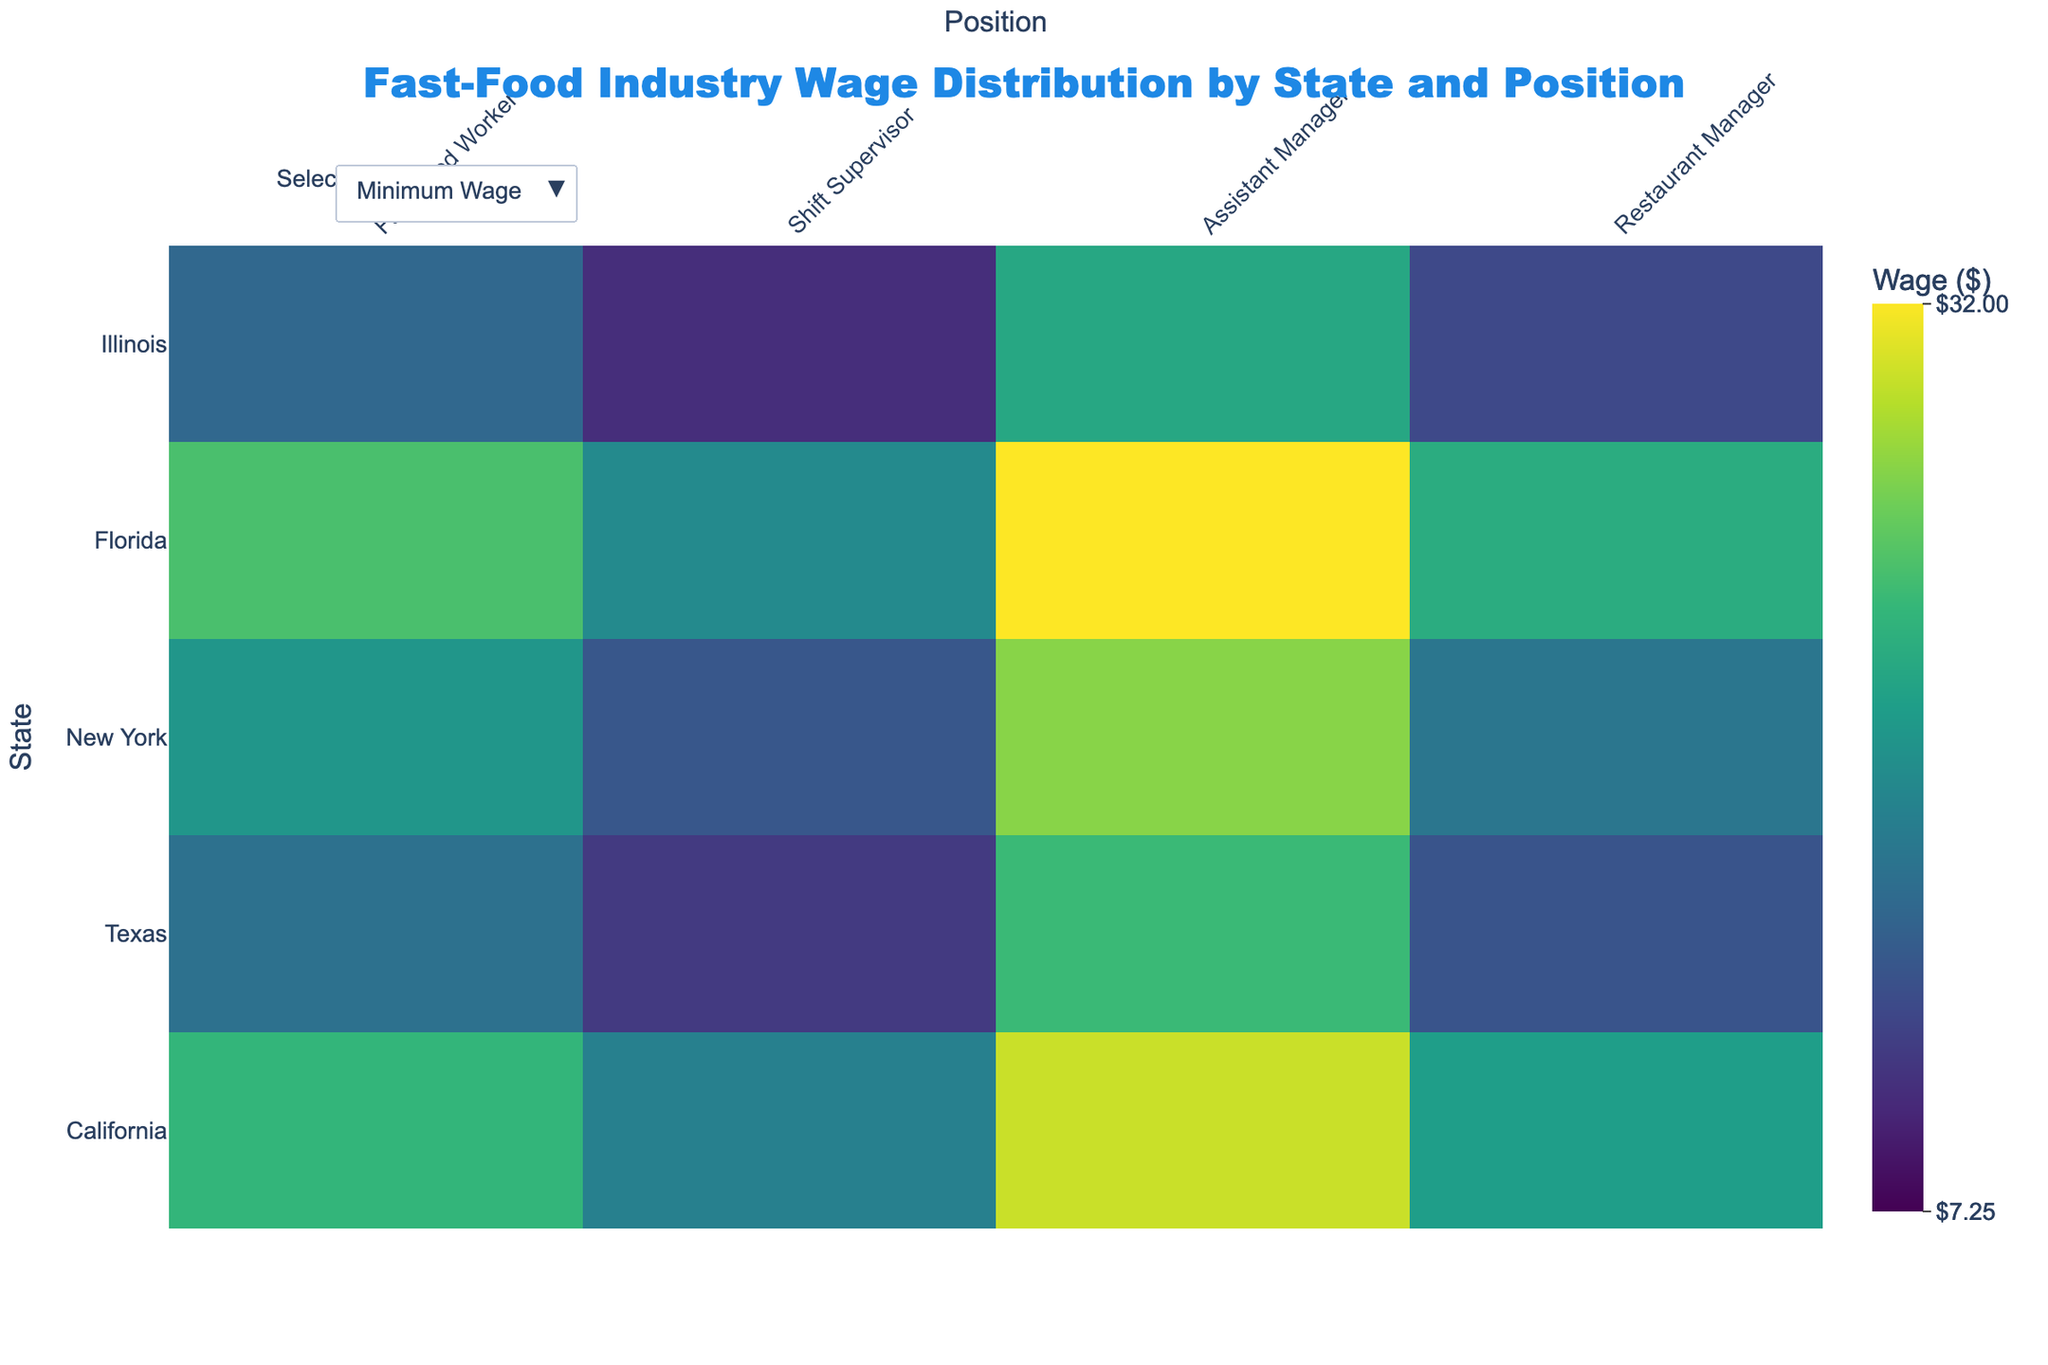What's the title of the figure? The title of the figure is displayed at the top center.
Answer: Fast-Food Industry Wage Distribution by State and Position Which state has the highest minimum wage for a Fast Food Worker? Look at the heatmap for minimum wages and find the highest value for the Fast Food Worker column, then check which state it corresponds to.
Answer: California What is the difference between the minimum and maximum wage for a Restaurant Manager in New York? Locate the cells for New York and Restaurant Manager in both the minimum and maximum wage heatmaps. Subtract the minimum wage from the maximum wage.
Answer: 8.50 Which state has the lowest maximum wage for a Shift Supervisor? Examine the heatmap for maximum wages and identify the smallest value in the Shift Supervisor column. Then see which state it is associated with.
Answer: Texas What is the average maximum wage for an Assistant Manager across all states? Find the maximum wages for Assistant Managers for each state, sum them up, and divide by the number of states. (23.50 + 15.50 + 24.75 + 16.50 + 20.25) / 5 = 20.50
Answer: 20.50 Which position in California has the smallest range between minimum and maximum wages? Calculate the difference between the minimum and maximum wages for each position in California and find the one with the smallest range.
Answer: Fast Food Worker 